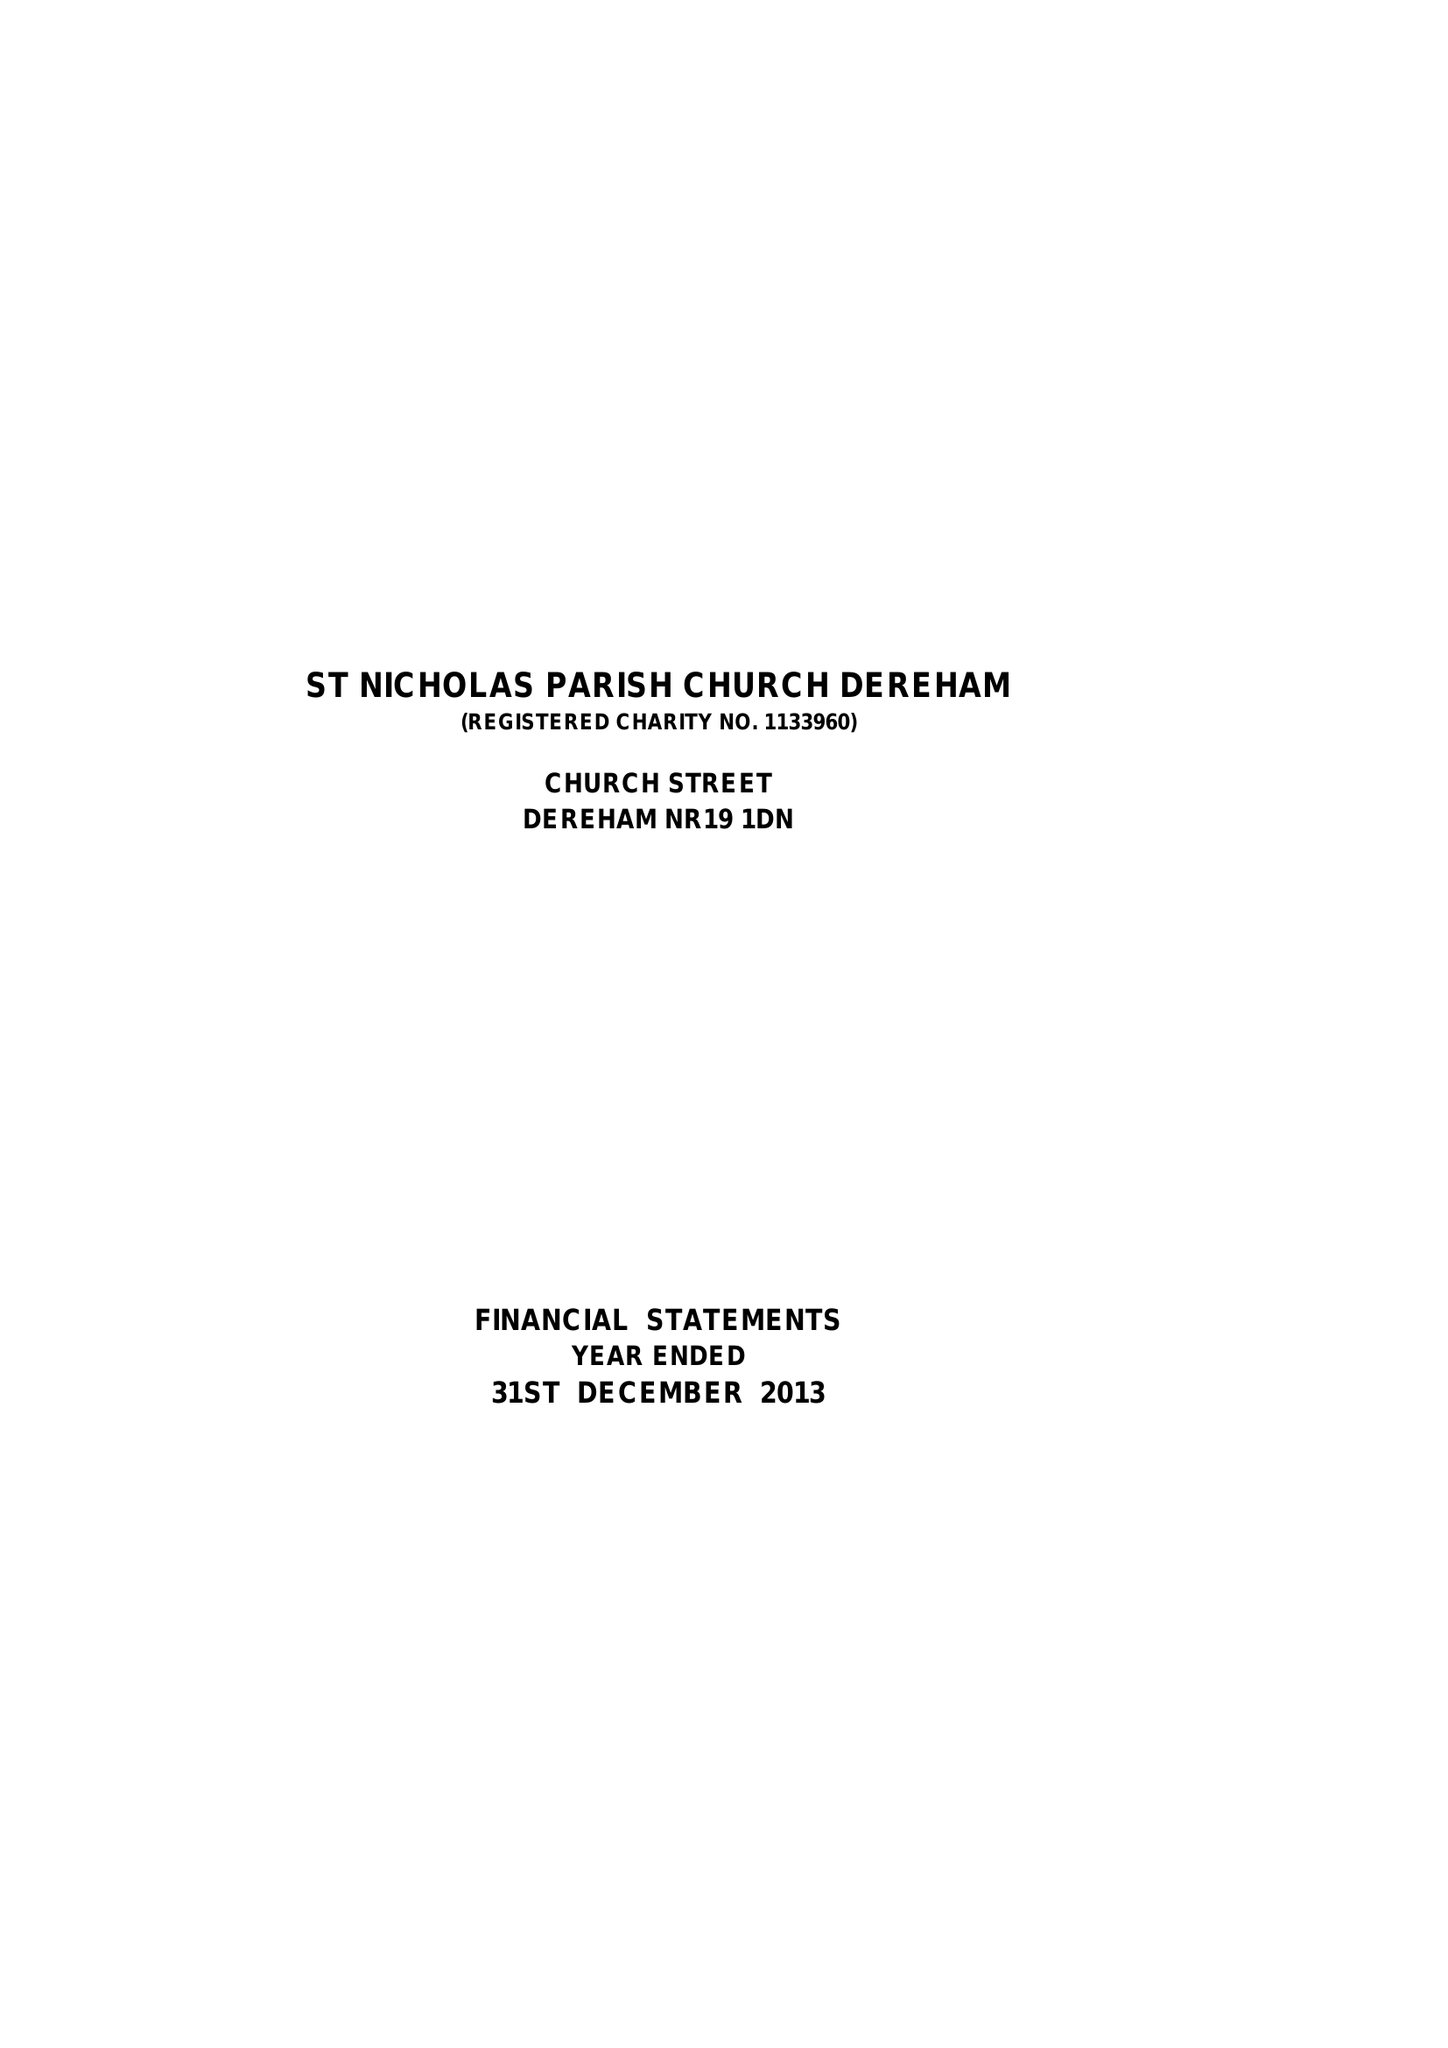What is the value for the charity_number?
Answer the question using a single word or phrase. 1133960 